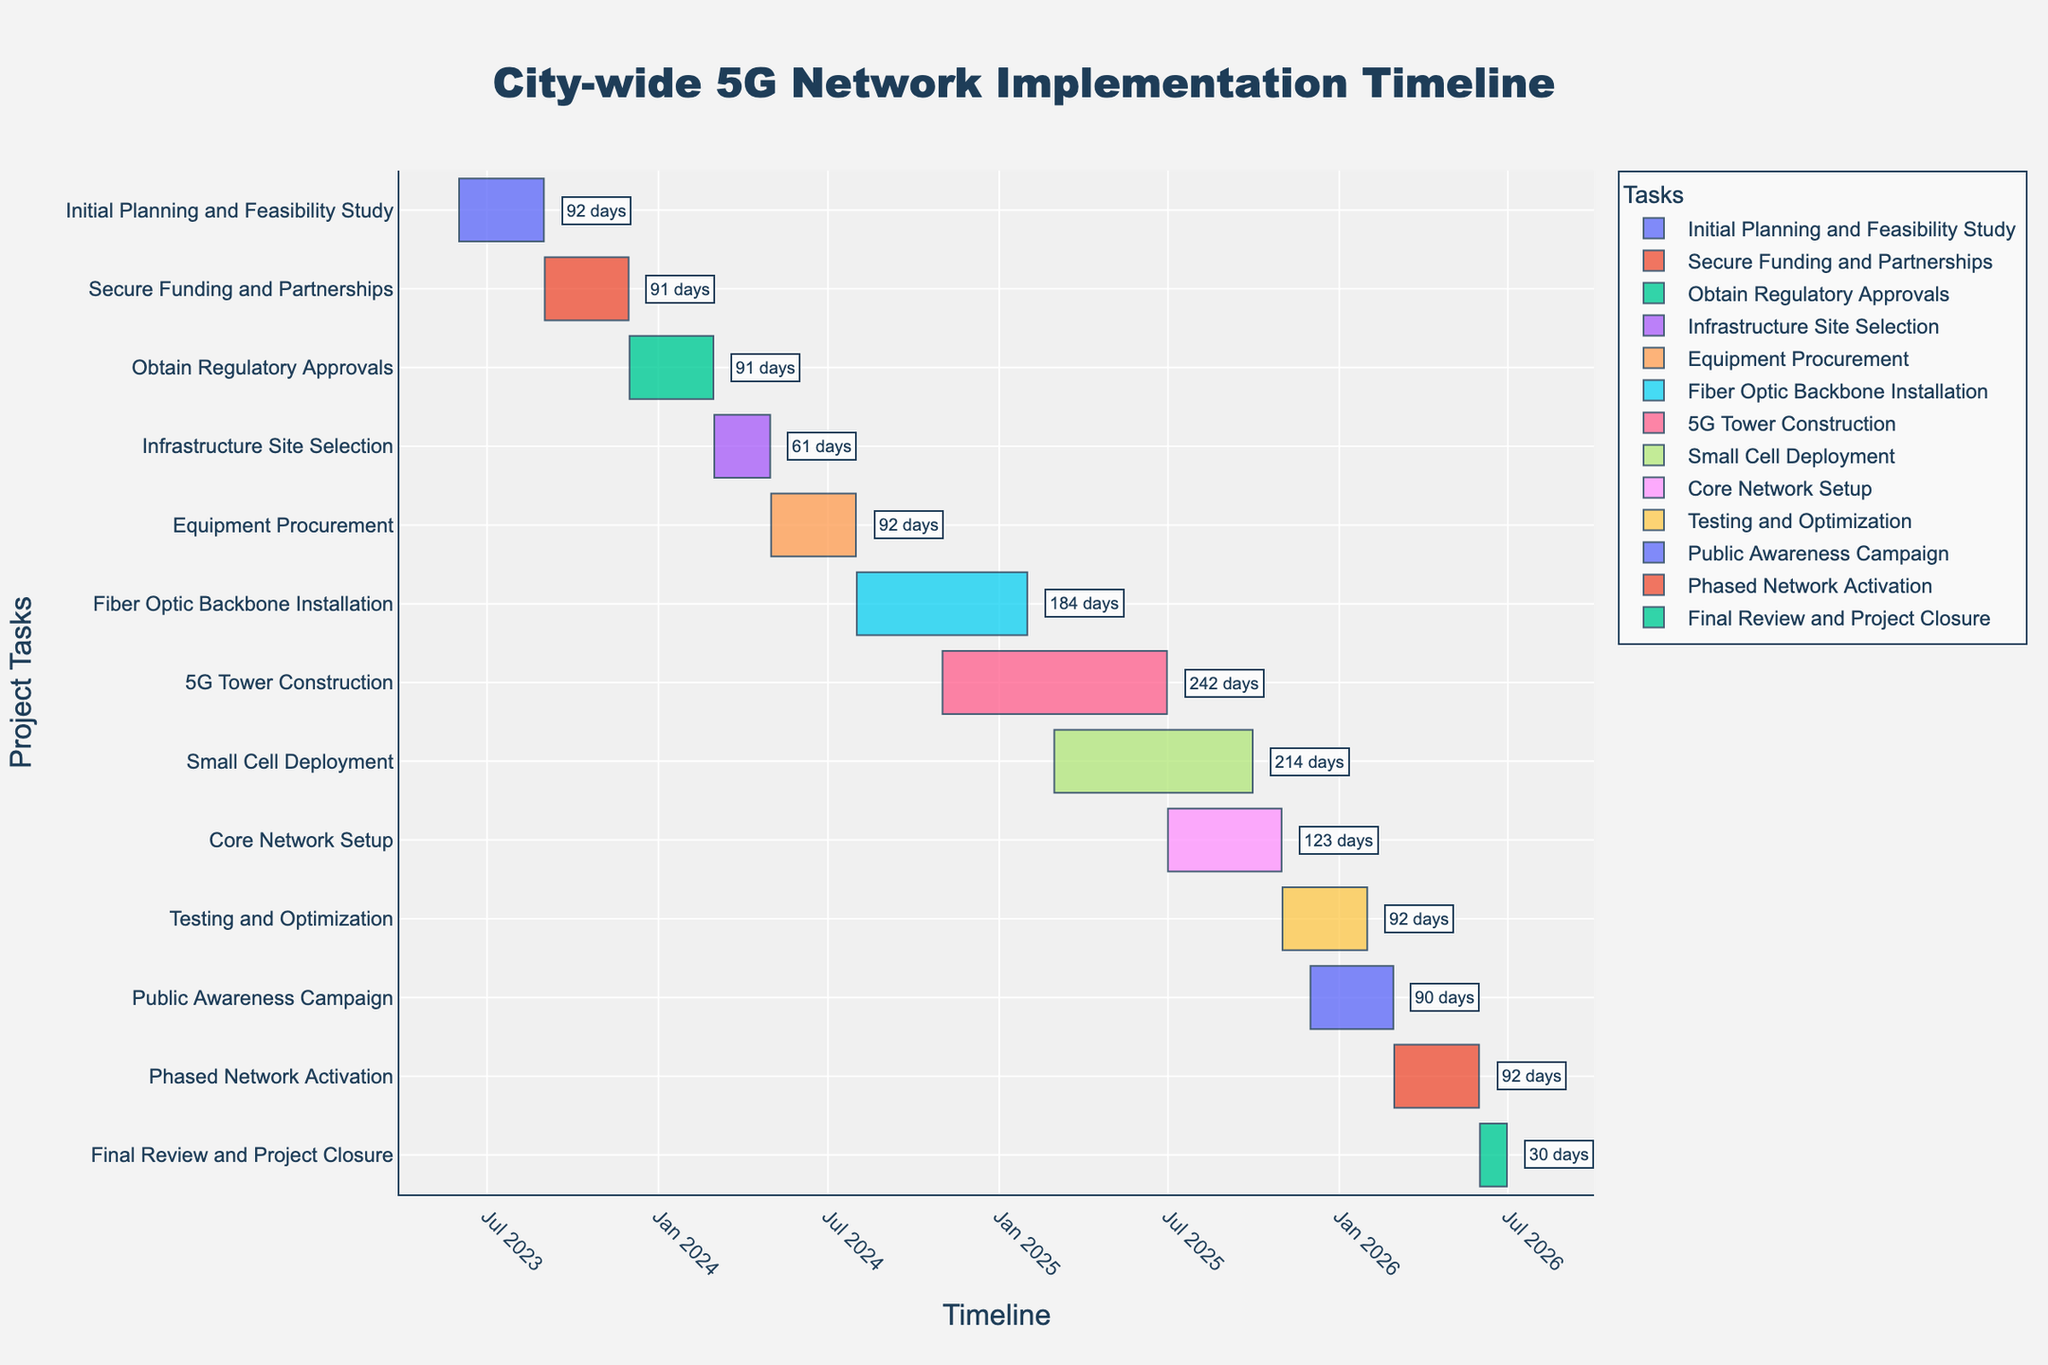What is the title of the Gantt chart? The title of the Gantt chart is located at the top center of the figure. It typically summarizes the main focus of the chart.
Answer: City-wide 5G Network Implementation Timeline How many tasks are involved in the project? Count the number of distinct tasks listed on the y-axis.
Answer: 12 Which task has the longest duration? Compare the duration annotations next to each task to identify the longest one. 5G Tower Construction has the duration of 242 days, which is the longest.
Answer: 5G Tower Construction What is the combined duration of Initial Planning and Feasibility Study and Secure Funding and Partnerships? Sum the durations of "Initial Planning and Feasibility Study" (92 days) and "Secure Funding and Partnerships" (91 days). The combined duration is 92 + 91 = 183 days.
Answer: 183 days Which tasks overlap in time during the period from March 2025 to September 2025? Identify tasks that have start and end dates within March 2025 to September 2025. "Small Cell Deployment" and "5G Tower Construction" overlap during this period.
Answer: Small Cell Deployment and 5G Tower Construction How much time does the Testing and Optimization phase last? Look at the duration annotation next to "Testing and Optimization". It lasts 92 days.
Answer: 92 days During which period will the Core Network Setup task be executed? Refer to the specific task's start and end dates. Core Network Setup is executed from July 1, 2025, to October 31, 2025.
Answer: July 1, 2025 - October 31, 2025 Are there any tasks beginning in 2026? If so, which ones? Check the start dates of all tasks and see which ones begin in 2026. "Phased Network Activation" and "Final Review and Project Closure" start in 2026.
Answer: Phased Network Activation and Final Review and Project Closure Which task is directly followed by Testing and Optimization? Identify the task listed immediately below "Testing and Optimization" in the Gantt chart. "Public Awareness Campaign" follows "Testing and Optimization".
Answer: Public Awareness Campaign 